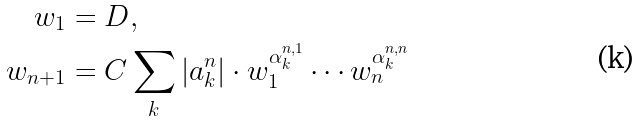<formula> <loc_0><loc_0><loc_500><loc_500>w _ { 1 } & = D , \\ w _ { n + 1 } & = C \sum _ { k } | a ^ { n } _ { k } | \cdot w _ { 1 } ^ { \alpha ^ { n , 1 } _ { k } } \cdots w _ { n } ^ { \alpha ^ { n , n } _ { k } }</formula> 